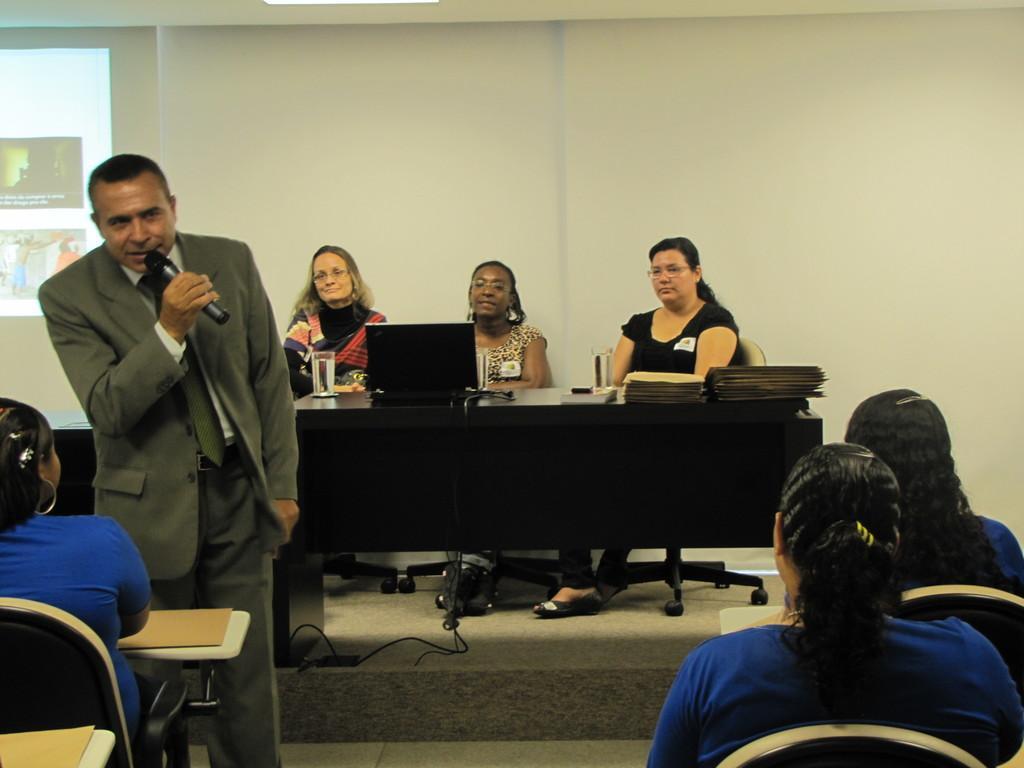Describe this image in one or two sentences. The person wearing suit is standing and speaking in front of a mic and there are group of people in front of him and there are three ladies sitting behind him. 